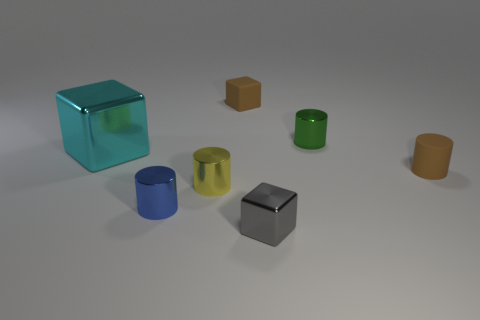Add 2 small yellow cylinders. How many objects exist? 9 Subtract all purple blocks. Subtract all red balls. How many blocks are left? 3 Subtract all cylinders. How many objects are left? 3 Subtract 1 brown blocks. How many objects are left? 6 Subtract all blue metallic cylinders. Subtract all tiny green cylinders. How many objects are left? 5 Add 4 large shiny cubes. How many large shiny cubes are left? 5 Add 4 big purple shiny cylinders. How many big purple shiny cylinders exist? 4 